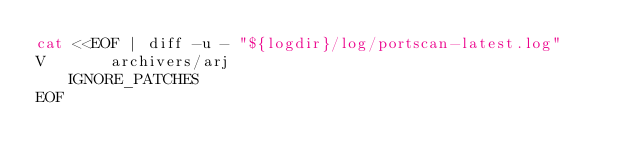<code> <loc_0><loc_0><loc_500><loc_500><_Bash_>cat <<EOF | diff -u - "${logdir}/log/portscan-latest.log"
V       archivers/arj                            IGNORE_PATCHES
EOF
</code> 